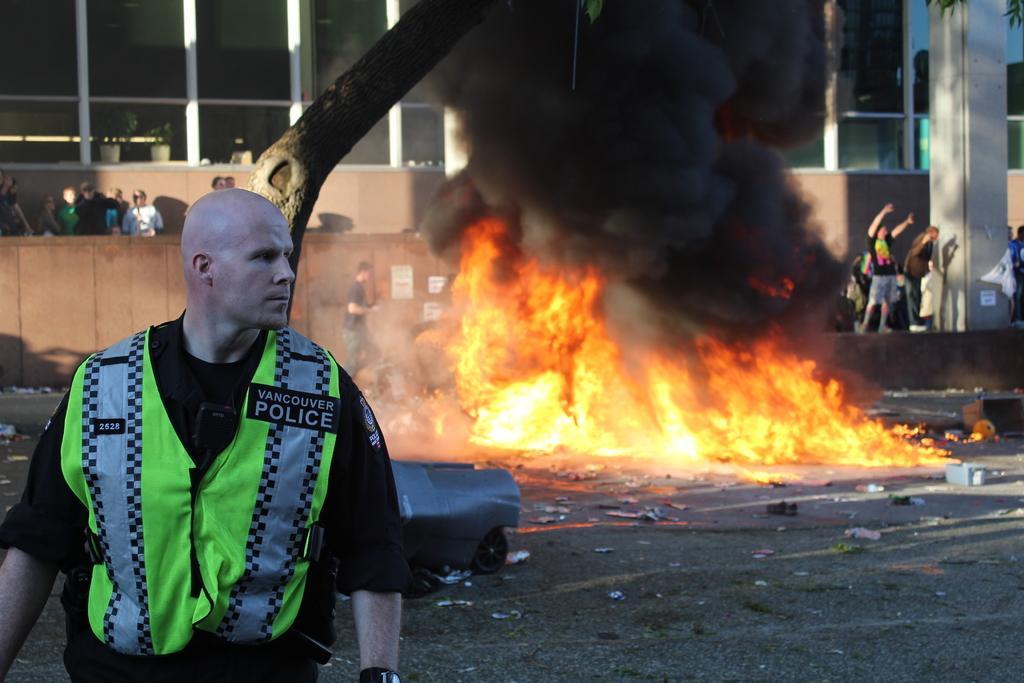Describe this image in one or two sentences. In the bottom left corner of the image a person is standing. Behind him there is fire. Behind the fire few people are standing. At the top of the image there is a building. 